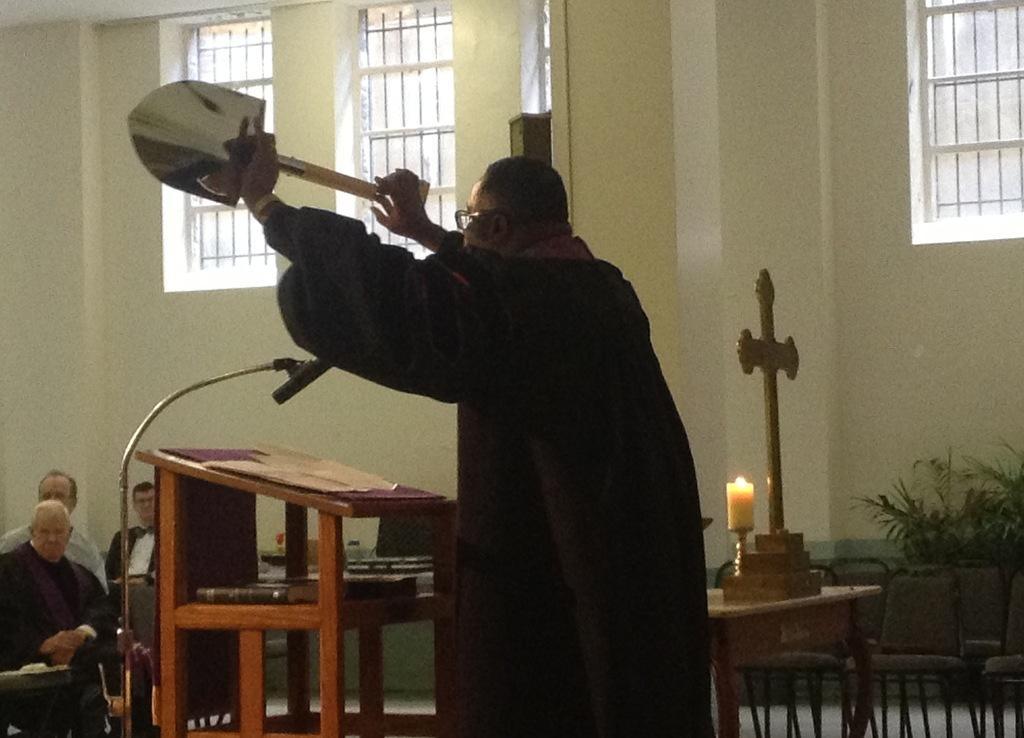Please provide a concise description of this image. I think this image is taken in a church. A person in black dress is holding a raft, in front of him there is a table and a bible on it. Towards the right there are some empty chairs and a plant. Towards the left there are some people. In the top there is a window. 